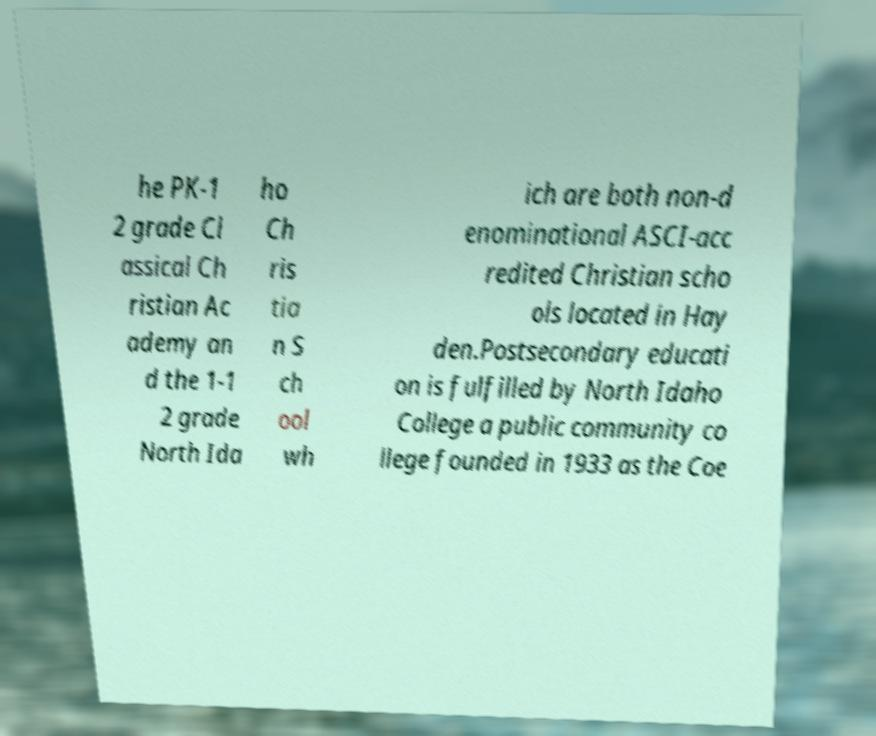For documentation purposes, I need the text within this image transcribed. Could you provide that? he PK-1 2 grade Cl assical Ch ristian Ac ademy an d the 1-1 2 grade North Ida ho Ch ris tia n S ch ool wh ich are both non-d enominational ASCI-acc redited Christian scho ols located in Hay den.Postsecondary educati on is fulfilled by North Idaho College a public community co llege founded in 1933 as the Coe 